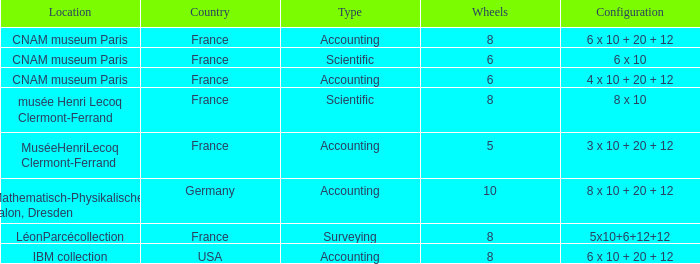What is the structure for the state france, with accounting as the variety, and wheels over 6? 6 x 10 + 20 + 12. Parse the table in full. {'header': ['Location', 'Country', 'Type', 'Wheels', 'Configuration'], 'rows': [['CNAM museum Paris', 'France', 'Accounting', '8', '6 x 10 + 20 + 12'], ['CNAM museum Paris', 'France', 'Scientific', '6', '6 x 10'], ['CNAM museum Paris', 'France', 'Accounting', '6', '4 x 10 + 20 + 12'], ['musée Henri Lecoq Clermont-Ferrand', 'France', 'Scientific', '8', '8 x 10'], ['MuséeHenriLecoq Clermont-Ferrand', 'France', 'Accounting', '5', '3 x 10 + 20 + 12'], ['Mathematisch-Physikalischer salon, Dresden', 'Germany', 'Accounting', '10', '8 x 10 + 20 + 12'], ['LéonParcécollection', 'France', 'Surveying', '8', '5x10+6+12+12'], ['IBM collection', 'USA', 'Accounting', '8', '6 x 10 + 20 + 12']]} 